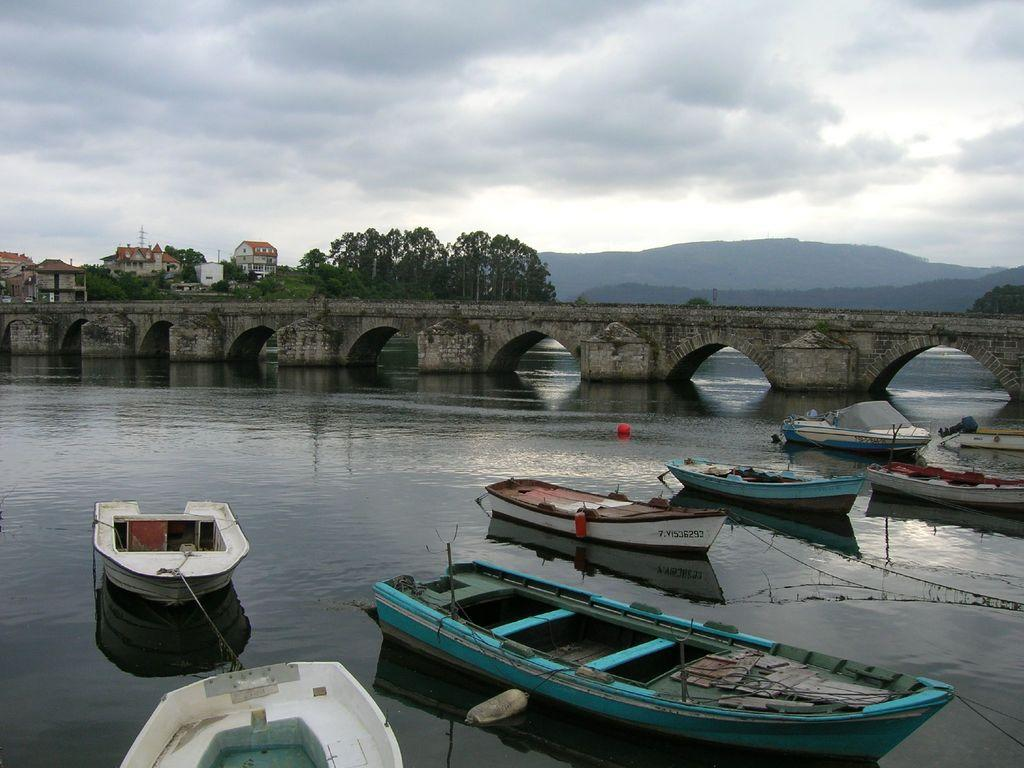What is in the water in the image? There are boats in the water in the image. What can be seen in the background of the image? There are trees, houses, hills, and clouds in the background of the image. Is there any structure that crosses over the water in the image? Yes, there is a bridge over the water in the image. What type of sofa can be seen floating in the water in the image? There is no sofa present in the image; it features boats in the water. Can you describe the tongue of the person in the image? There is no person present in the image, so it is not possible to describe their tongue. 